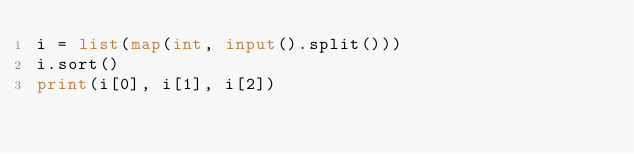<code> <loc_0><loc_0><loc_500><loc_500><_Python_>i = list(map(int, input().split()))
i.sort()
print(i[0], i[1], i[2])
</code> 